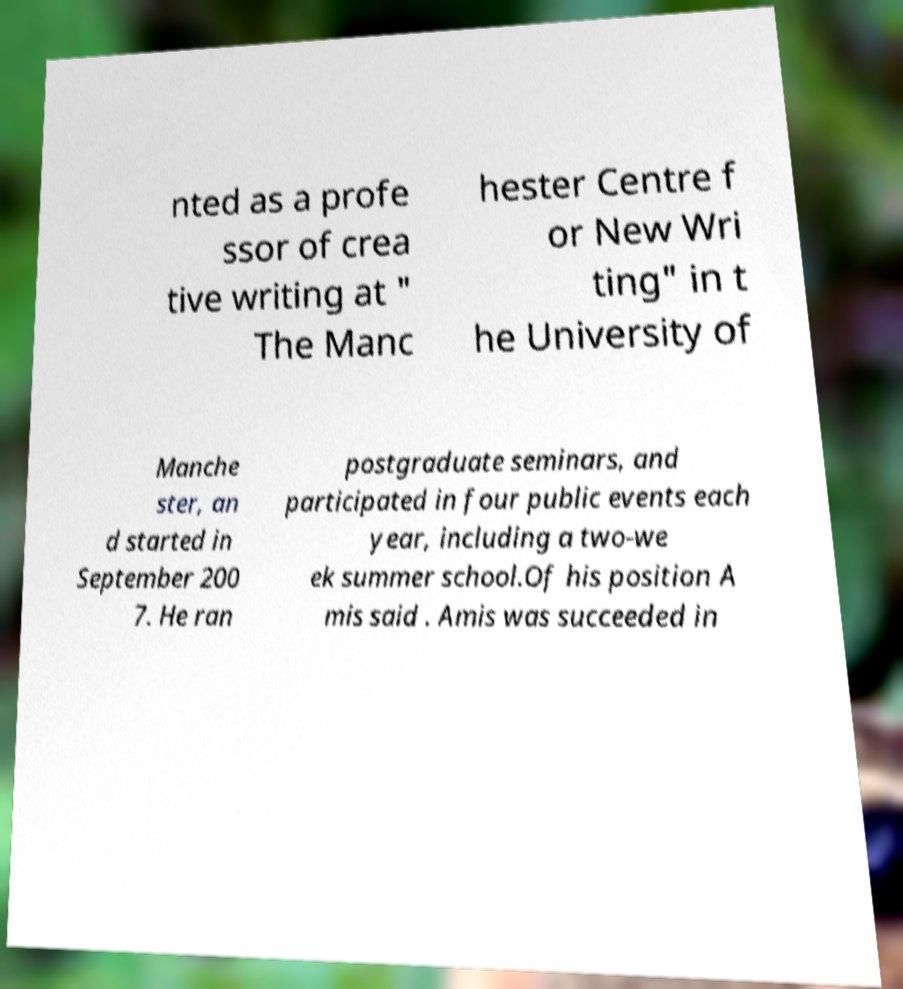What messages or text are displayed in this image? I need them in a readable, typed format. nted as a profe ssor of crea tive writing at " The Manc hester Centre f or New Wri ting" in t he University of Manche ster, an d started in September 200 7. He ran postgraduate seminars, and participated in four public events each year, including a two-we ek summer school.Of his position A mis said . Amis was succeeded in 